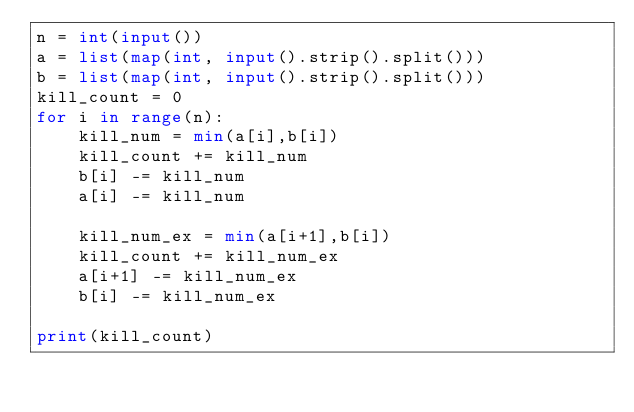<code> <loc_0><loc_0><loc_500><loc_500><_Python_>n = int(input())
a = list(map(int, input().strip().split()))
b = list(map(int, input().strip().split()))
kill_count = 0
for i in range(n):
    kill_num = min(a[i],b[i])
    kill_count += kill_num
    b[i] -= kill_num
    a[i] -= kill_num

    kill_num_ex = min(a[i+1],b[i])
    kill_count += kill_num_ex
    a[i+1] -= kill_num_ex
    b[i] -= kill_num_ex

print(kill_count)</code> 